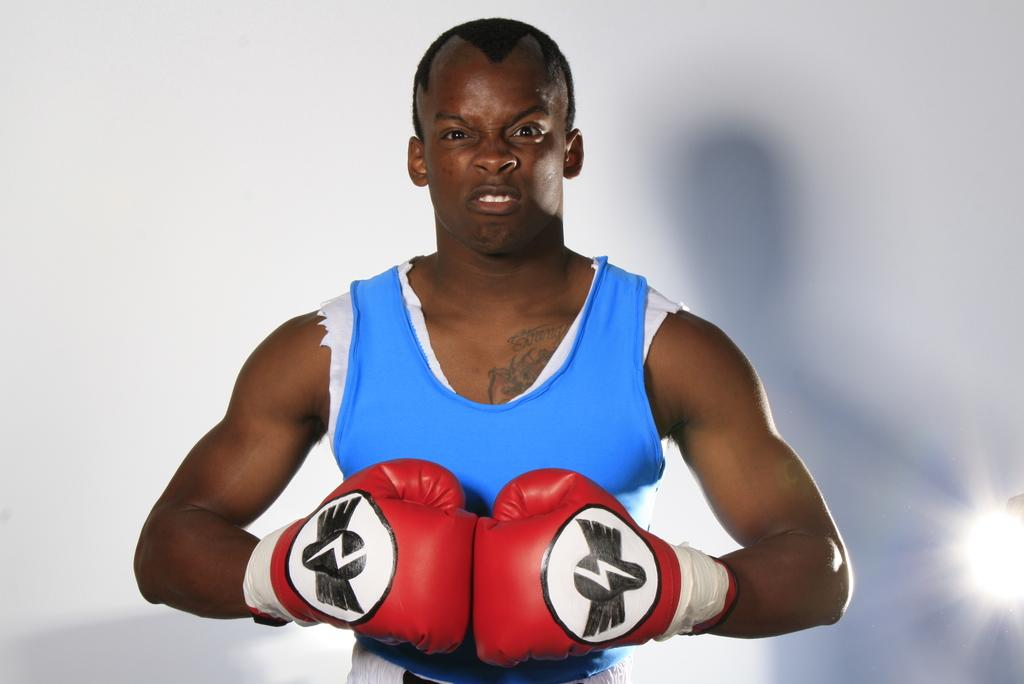What is the main subject of the image? There is a person in the image. What is the person wearing? The person is wearing boxing gloves. What color is the background of the image? The background of the image is white. Where is the light source located in the image? There is a light on the right side of the image. What religious symbols can be seen in the image? There are no religious symbols present in the image. What hobbies does the person in the image have? The image does not provide information about the person's hobbies. 